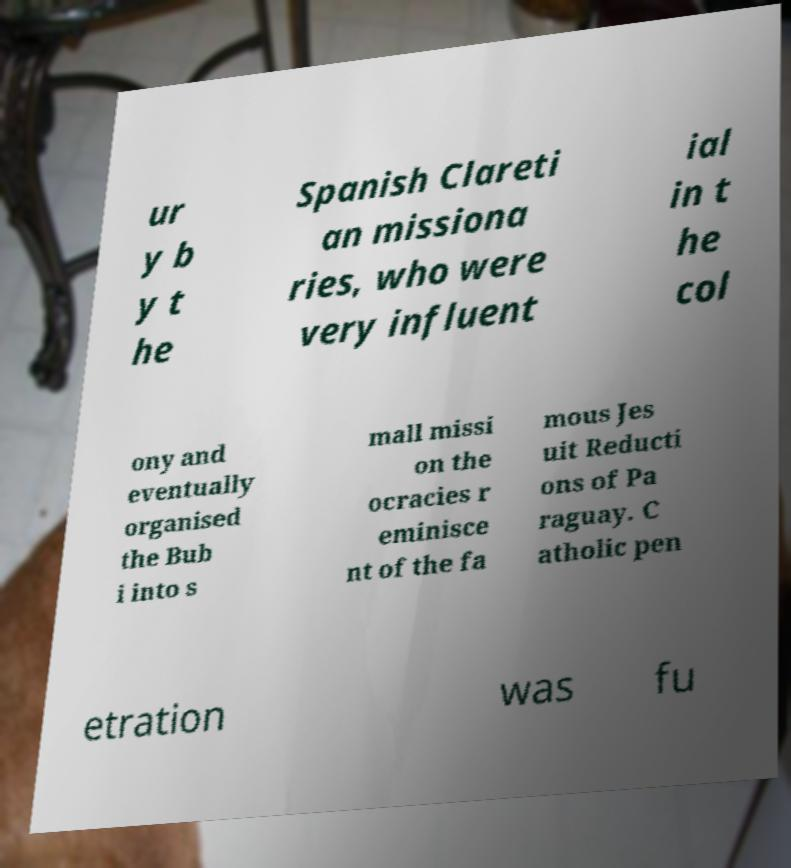For documentation purposes, I need the text within this image transcribed. Could you provide that? ur y b y t he Spanish Clareti an missiona ries, who were very influent ial in t he col ony and eventually organised the Bub i into s mall missi on the ocracies r eminisce nt of the fa mous Jes uit Reducti ons of Pa raguay. C atholic pen etration was fu 